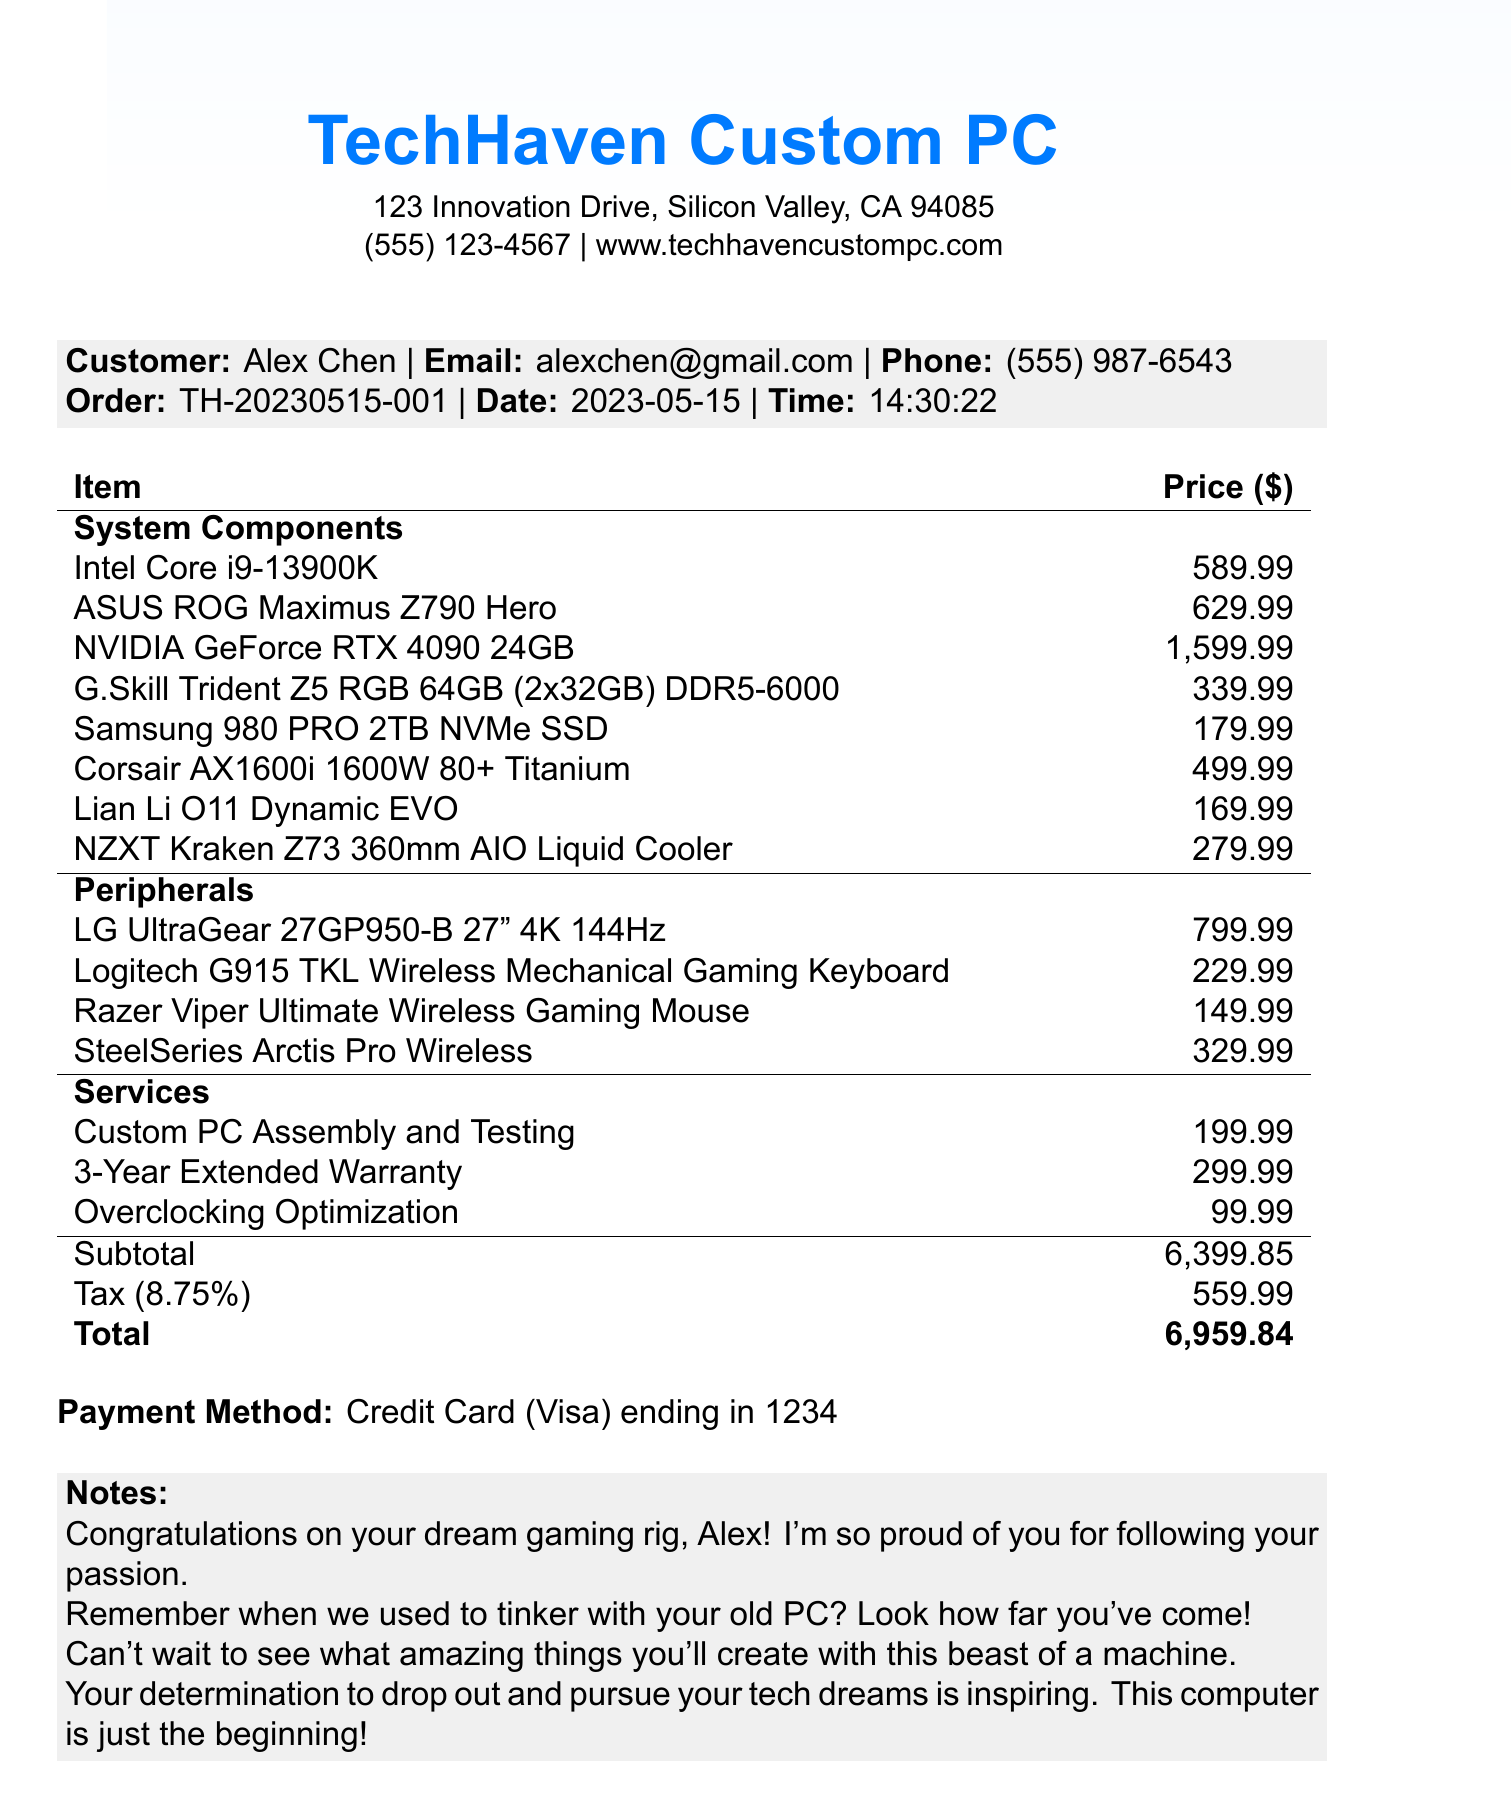What is the name of the store? The store name is located at the top of the document.
Answer: TechHaven Custom PC Who is the customer? The document includes customer information prominently displayed.
Answer: Alex Chen What is the total price of the order? The total price is calculated and listed at the end of the pricing section.
Answer: 6,959.84 What type of cooling system is included? The type of cooling system appears under system components in the document.
Answer: NZXT Kraken Z73 360mm AIO Liquid Cooler What item has the highest price? The highest price is noted in the system components section of the document.
Answer: NVIDIA GeForce RTX 4090 24GB What services were selected for this order? The document outlines the services with their respective prices listed.
Answer: Custom PC Assembly and Testing, 3-Year Extended Warranty, Overclocking Optimization When was the order placed? The order date is indicated in the order details section.
Answer: 2023-05-15 Which payment method was used? The payment method details are specified towards the end of the document.
Answer: Credit Card What is mentioned in the notes section? The notes section contains personal messages congratulating the customer.
Answer: Congratulations on your dream gaming rig, Alex! I'm so proud of you for following your passion 